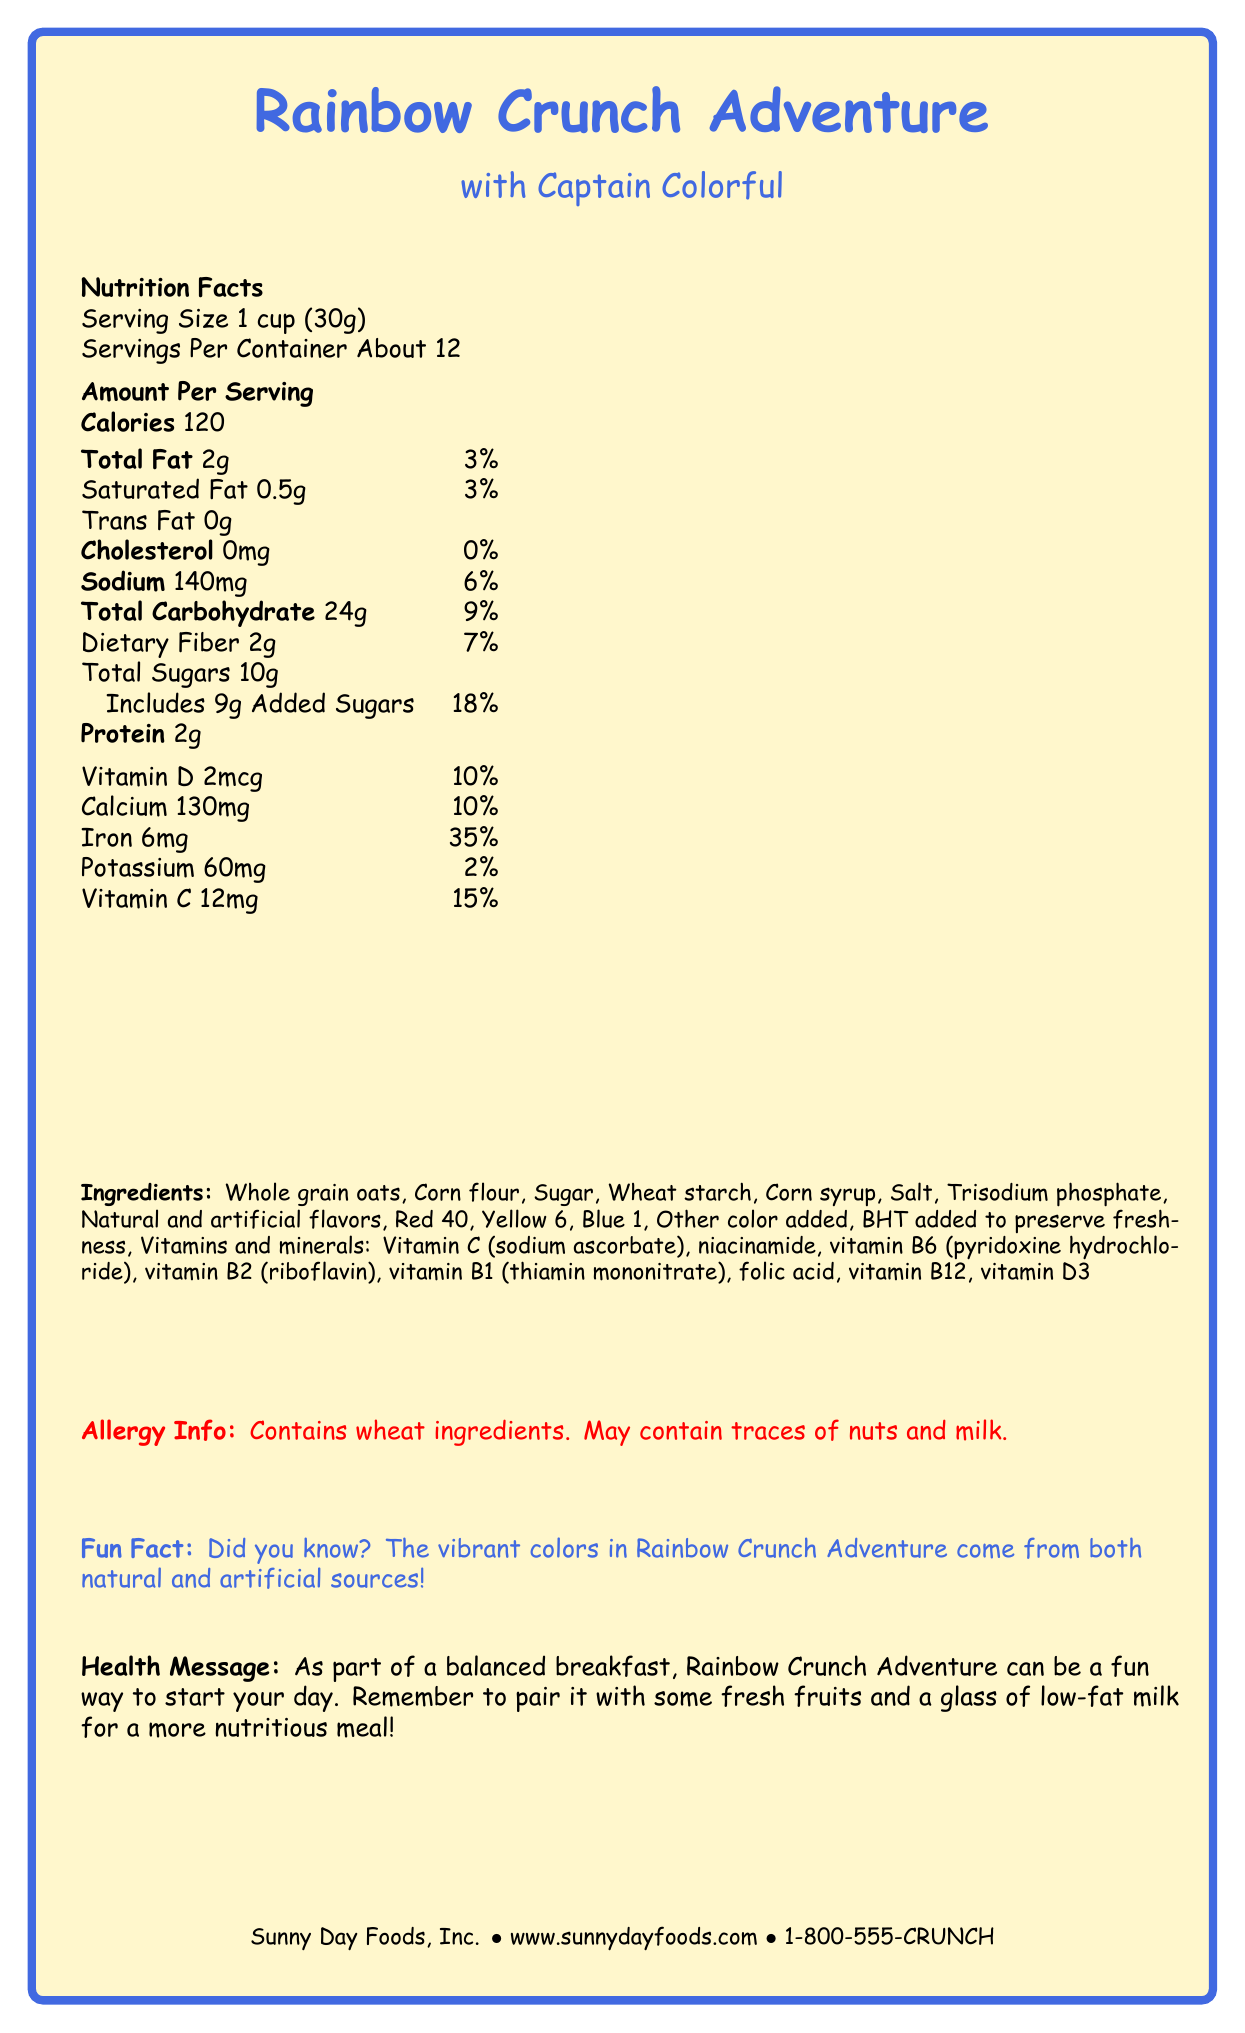What is the serving size of Rainbow Crunch Adventure? The serving size is directly mentioned under the Nutrition Facts section as "Serving Size 1 cup (30g)."
Answer: 1 cup (30g) How many servings are in the container? The number of servings per container is stated as "About 12" under the Nutrition Facts section.
Answer: About 12 What is the total carbohydrate content per serving? According to the Nutrition Facts label, the total carbohydrate content per serving is listed as 24g.
Answer: 24g How much added sugar is in one serving? The total added sugars in one serving are explicitly noted as 9g in the Nutrition Facts section.
Answer: 9g What is the name of the cereal's mascot? The document states that the mascot for Rainbow Crunch Adventure is Captain Colorful.
Answer: Captain Colorful How much iron does one serving provide as a percentage of the daily value? The Nutrition Facts label lists that one serving provides 35% of the daily value for iron.
Answer: 35% What are the main ingredients of Rainbow Crunch Adventure cereal? This information is listed in the Ingredients section.
Answer: Whole grain oats, Corn flour, Sugar, Wheat starch, Corn syrup, Salt, Trisodium phosphate, Natural and artificial flavors, Red 40, Yellow 6, Blue 1, Other color added, BHT, and various vitamins and minerals How much protein is in each serving of the cereal? The Nutrition Facts section lists that each serving contains 2g of protein.
Answer: 2g Which of the following nutrients does Rainbow Crunch Adventure provide the most of in terms of percentage Daily Value?
A. Vitamin D
B. Calcium
C. Iron
D. Sodium Iron has the highest percentage Daily Value per serving at 35%, while Vitamin D and Calcium are both at 10% and Sodium is at 6%.
Answer: C. Iron What is the main synthetic preservative listed in the ingredients? 
A. BHT 
B. Red 40 
C. Trisodium phosphate 
D. Corn syrup BHT is mentioned specifically as being added to preserve freshness, which makes it the main synthetic preservative listed.
Answer: A. BHT Does Rainbow Crunch Adventure contain any cholesterol? According to the Nutrition Facts label, the cereal contains 0mg of cholesterol.
Answer: No Summarize the main idea of the document. The document describes the nutritional composition, ingredient list, and fun elements of Rainbow Crunch Adventure, while also highlighting health messages and company information.
Answer: Rainbow Crunch Adventure is a colorful, cartoon mascot-backed cereal designed for a fun breakfast experience. It contains a mix of natural and artificial ingredients, provides various nutrients like iron and calcium, and has added sugar. It is produced by Sunny Day Foods, Inc. Can I determine the exact price of the Rainbow Crunch Adventure cereal from the document? The document provides detailed nutritional and company information but does not mention the price of the cereal.
Answer: Not enough information 